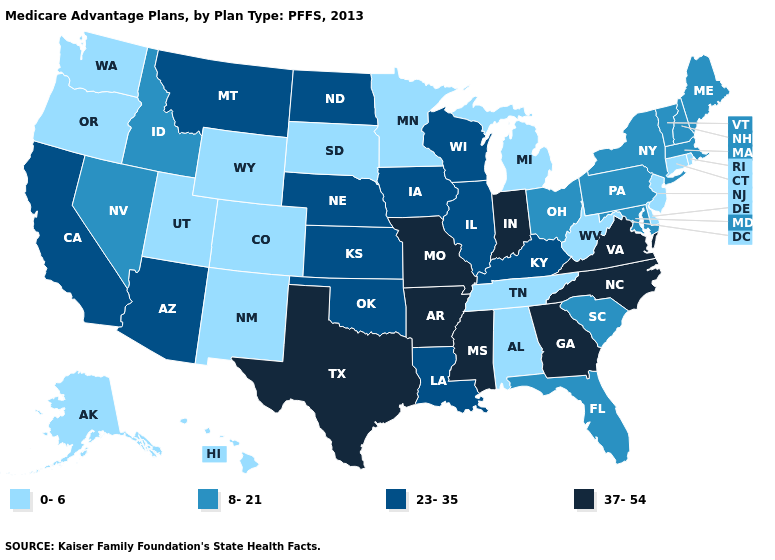Does Iowa have a higher value than New Jersey?
Give a very brief answer. Yes. What is the lowest value in states that border California?
Write a very short answer. 0-6. Does the map have missing data?
Write a very short answer. No. What is the value of New Hampshire?
Answer briefly. 8-21. Among the states that border South Dakota , which have the lowest value?
Write a very short answer. Minnesota, Wyoming. Does North Carolina have the highest value in the USA?
Concise answer only. Yes. Name the states that have a value in the range 23-35?
Concise answer only. Arizona, California, Iowa, Illinois, Kansas, Kentucky, Louisiana, Montana, North Dakota, Nebraska, Oklahoma, Wisconsin. How many symbols are there in the legend?
Write a very short answer. 4. Name the states that have a value in the range 8-21?
Answer briefly. Florida, Idaho, Massachusetts, Maryland, Maine, New Hampshire, Nevada, New York, Ohio, Pennsylvania, South Carolina, Vermont. What is the value of Nevada?
Be succinct. 8-21. Among the states that border California , which have the highest value?
Short answer required. Arizona. What is the value of Colorado?
Write a very short answer. 0-6. What is the value of Texas?
Short answer required. 37-54. What is the highest value in the USA?
Give a very brief answer. 37-54. What is the lowest value in the Northeast?
Write a very short answer. 0-6. 